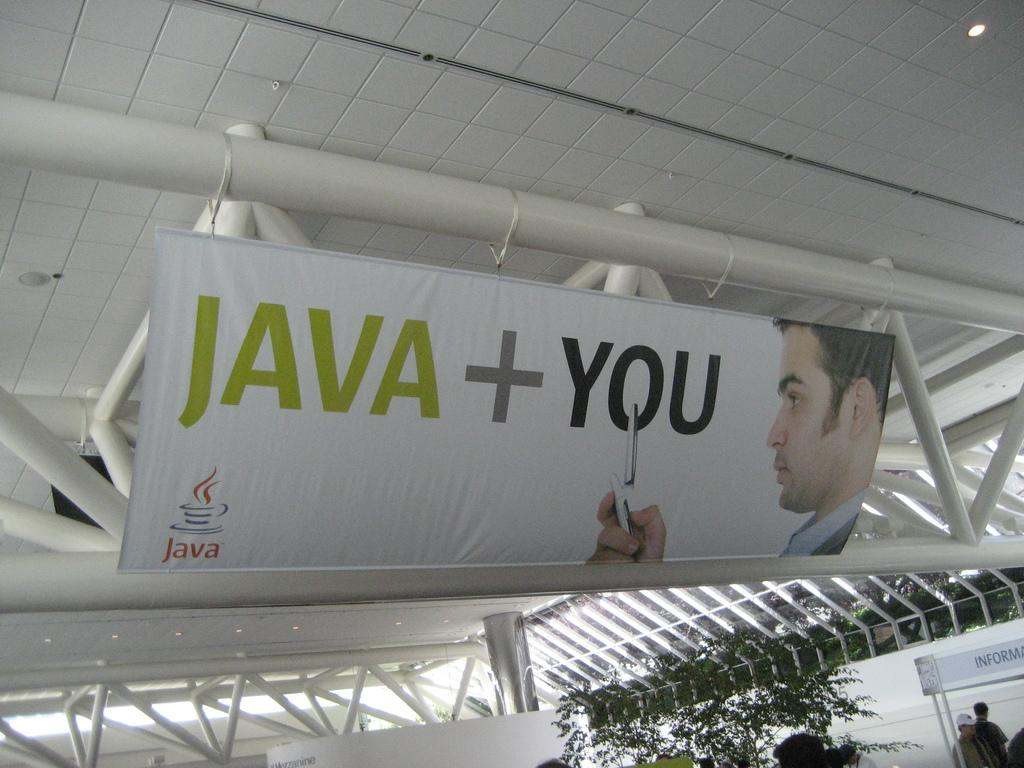<image>
Give a short and clear explanation of the subsequent image. A poster suspended from a ceiling depicting a man looking at a phone with the phrase "Java + You". 